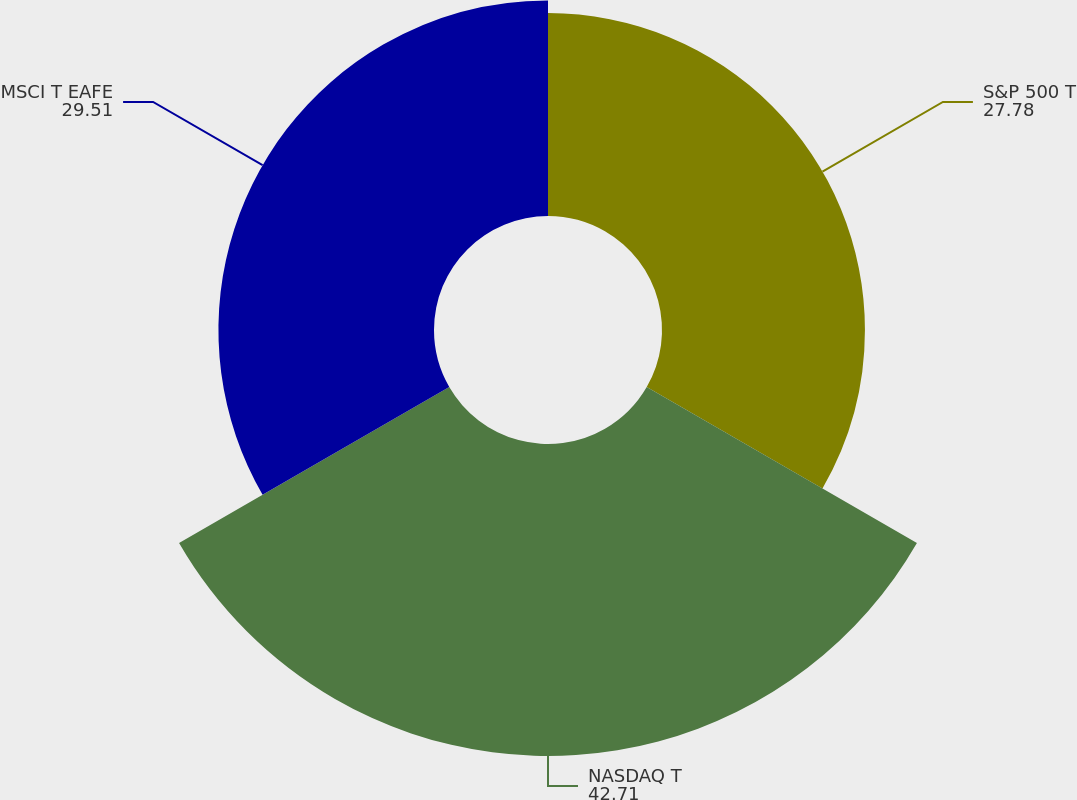Convert chart. <chart><loc_0><loc_0><loc_500><loc_500><pie_chart><fcel>S&P 500 T<fcel>NASDAQ T<fcel>MSCI T EAFE<nl><fcel>27.78%<fcel>42.71%<fcel>29.51%<nl></chart> 